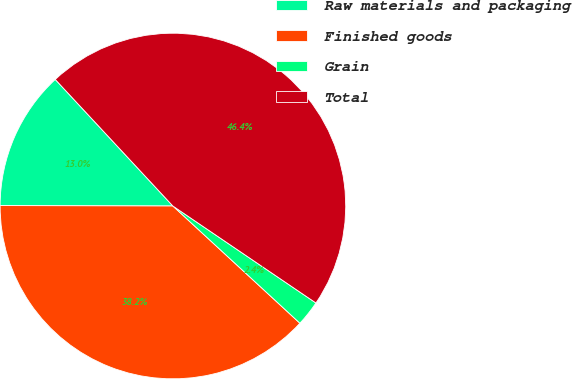<chart> <loc_0><loc_0><loc_500><loc_500><pie_chart><fcel>Raw materials and packaging<fcel>Finished goods<fcel>Grain<fcel>Total<nl><fcel>13.04%<fcel>38.18%<fcel>2.38%<fcel>46.4%<nl></chart> 